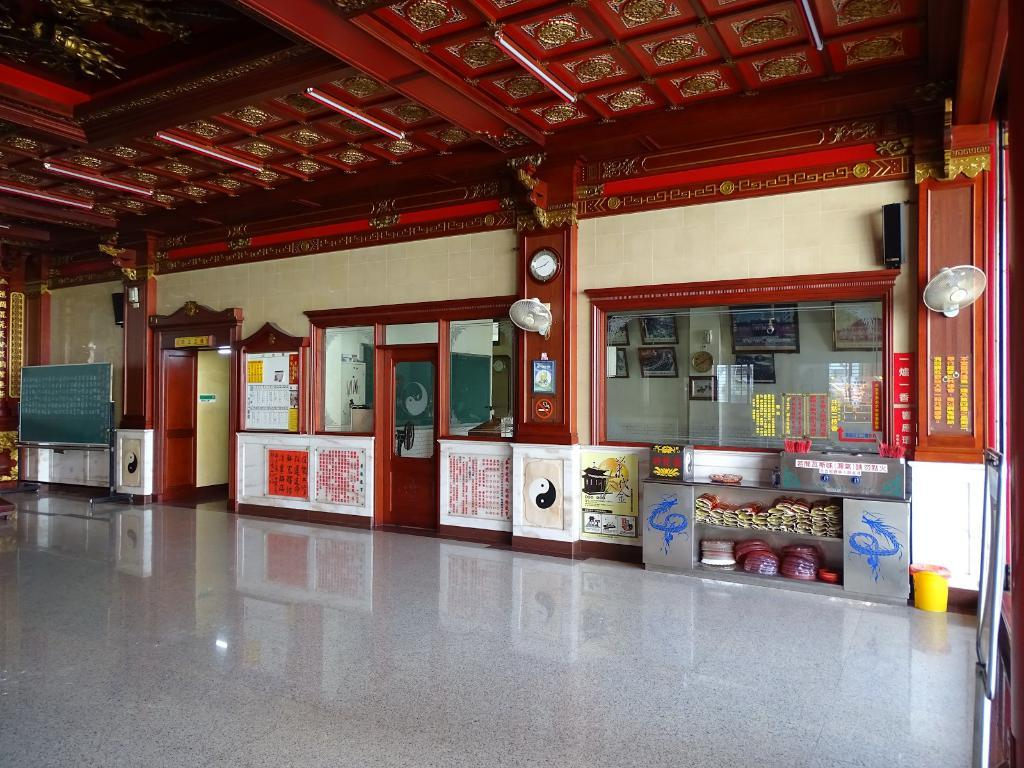<image>
Relay a brief, clear account of the picture shown. An indoor shopping area with a clock with it's hour hand on the number 8 